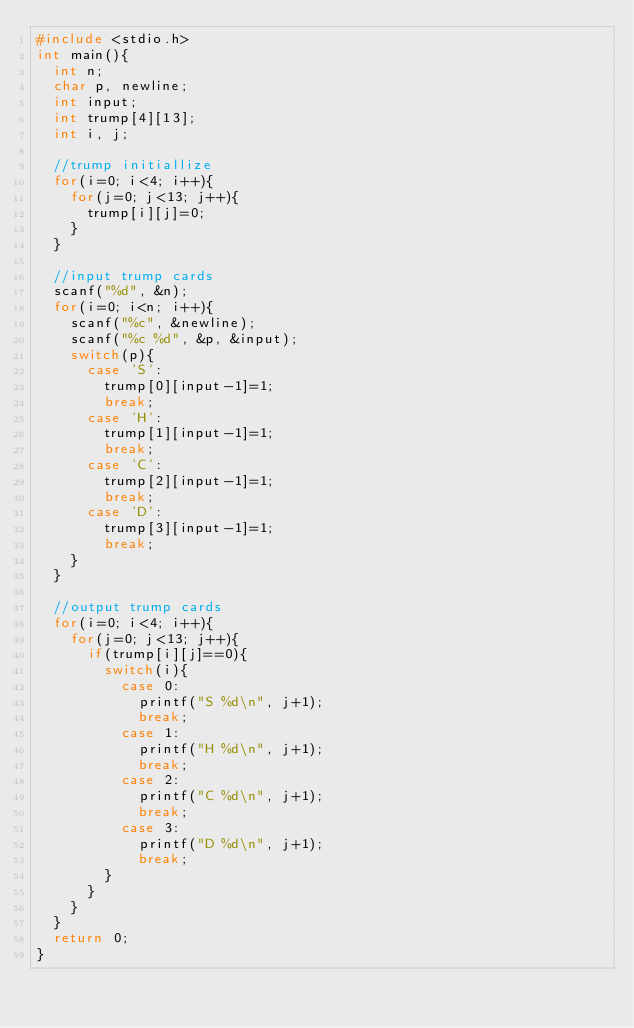Convert code to text. <code><loc_0><loc_0><loc_500><loc_500><_C_>#include <stdio.h>
int main(){
  int n;
  char p, newline;
  int input;
  int trump[4][13];
  int i, j;

  //trump initiallize
  for(i=0; i<4; i++){
    for(j=0; j<13; j++){
      trump[i][j]=0;
    }
  }

  //input trump cards
  scanf("%d", &n);
  for(i=0; i<n; i++){
    scanf("%c", &newline);
    scanf("%c %d", &p, &input);
    switch(p){
      case 'S':
        trump[0][input-1]=1;
        break;
      case 'H':
        trump[1][input-1]=1;
        break;
      case 'C':
        trump[2][input-1]=1;
        break;
      case 'D':
        trump[3][input-1]=1;
        break;
    }
  }

  //output trump cards
  for(i=0; i<4; i++){
    for(j=0; j<13; j++){
      if(trump[i][j]==0){
        switch(i){
          case 0:
            printf("S %d\n", j+1);
            break;
          case 1:
            printf("H %d\n", j+1);
            break;
          case 2:
            printf("C %d\n", j+1);
            break;
          case 3:
            printf("D %d\n", j+1);
            break;
        }
      }
    }
  }
  return 0;
}
</code> 